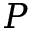Convert formula to latex. <formula><loc_0><loc_0><loc_500><loc_500>P</formula> 